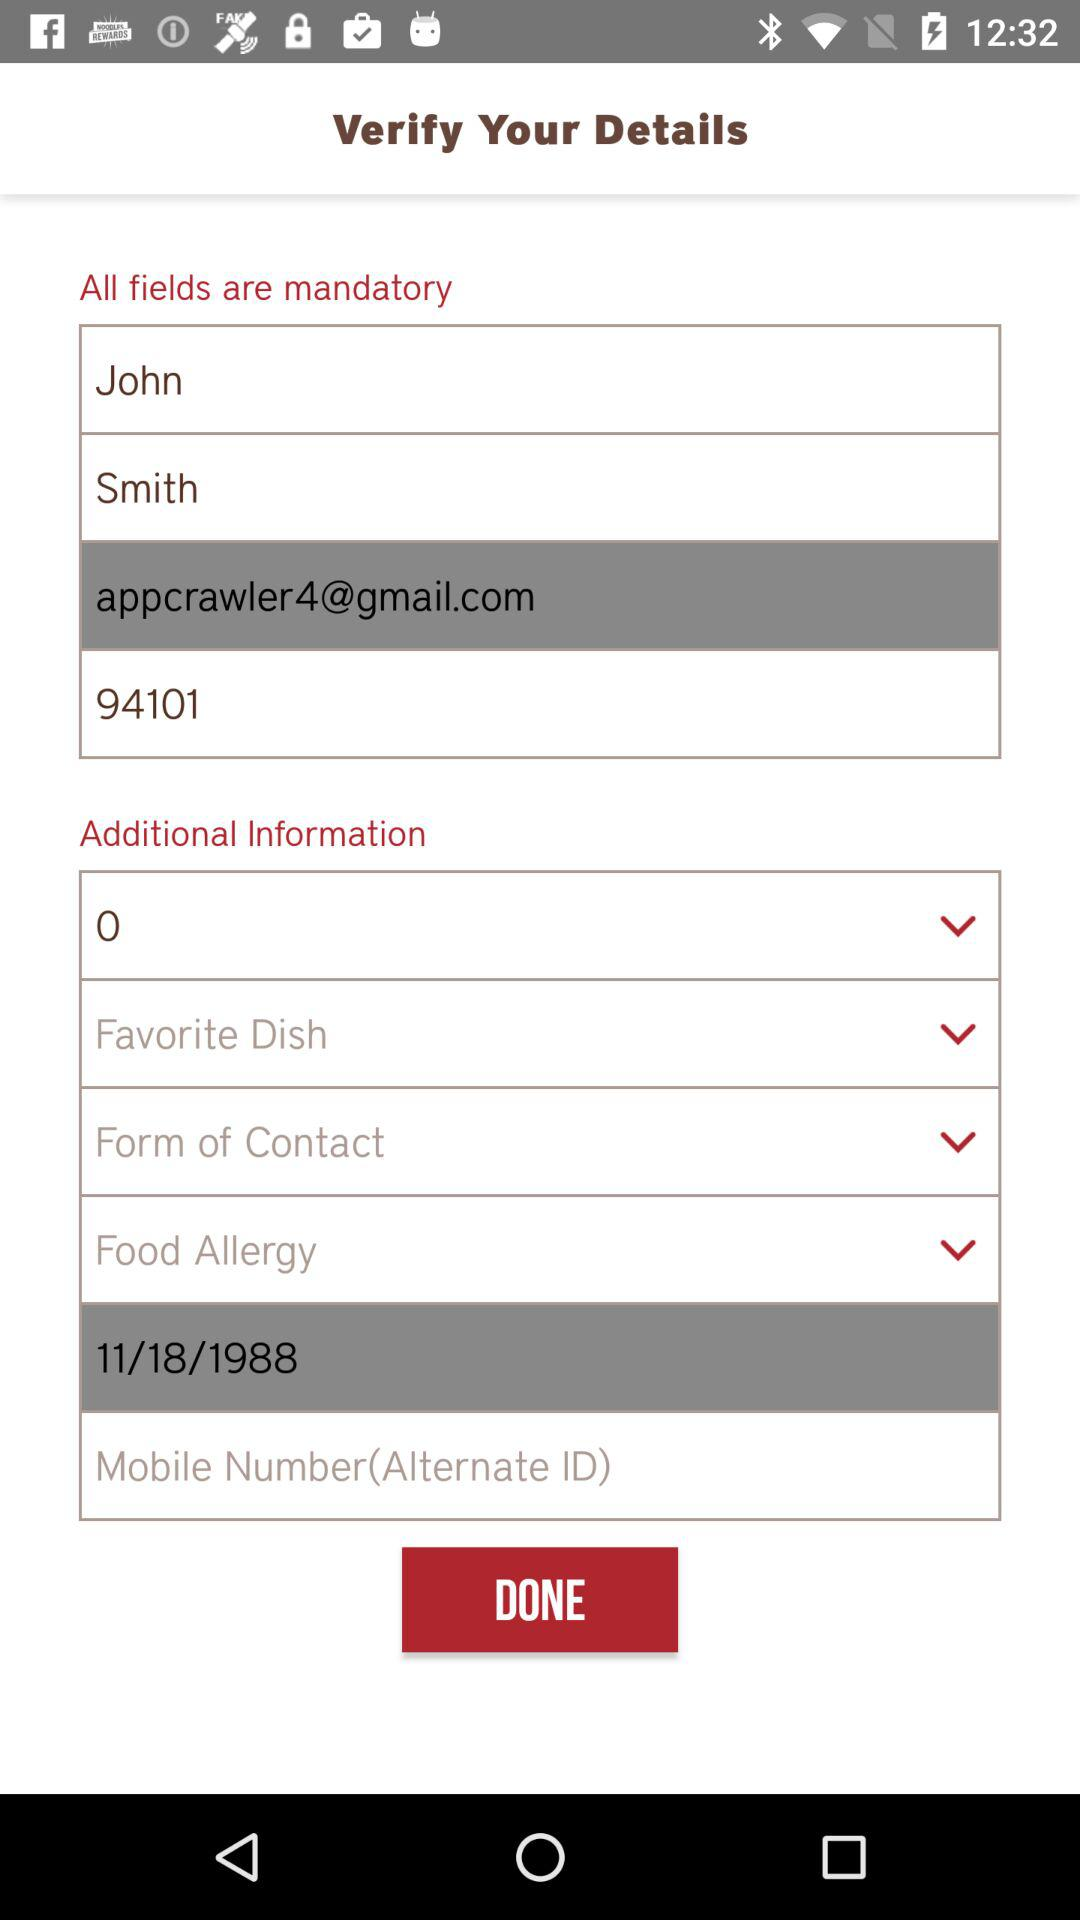How many "Food Allergy" options are available?
When the provided information is insufficient, respond with <no answer>. <no answer> 